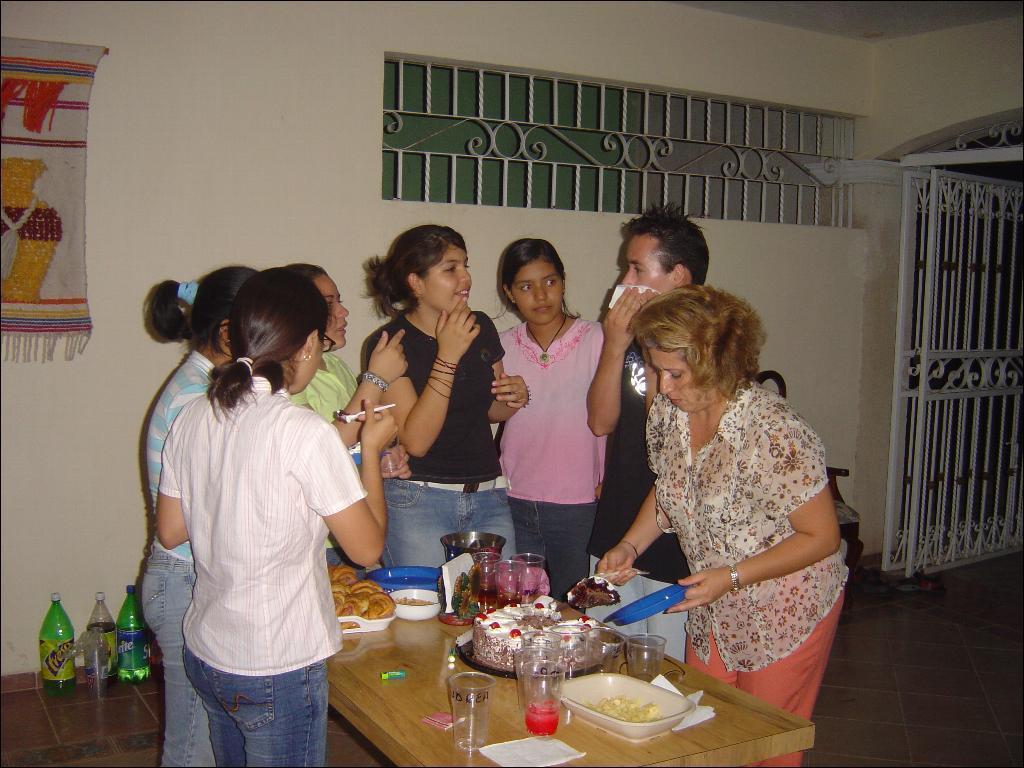Describe this image in one or two sentences. In the picture I can see a few persons standing on the floor. There is a man on the right side is holding a tissue paper in his right hand. I can see a woman on the right side is holding a blue color plate in her right hand. I can see the wooden table on the floor. I can see the glasses and bowls are kept on the table. I can see the water bottles on the floor. I can see a metal gate on the right side. 